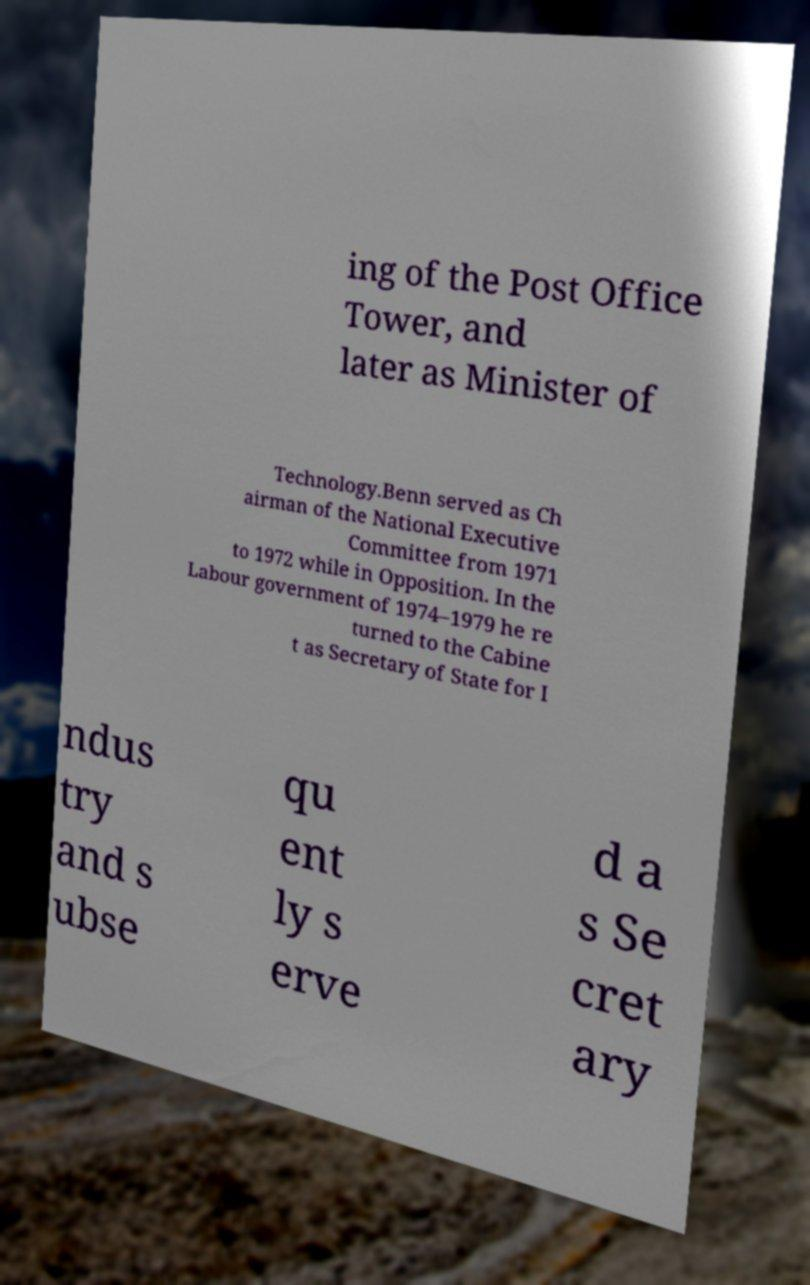Please read and relay the text visible in this image. What does it say? ing of the Post Office Tower, and later as Minister of Technology.Benn served as Ch airman of the National Executive Committee from 1971 to 1972 while in Opposition. In the Labour government of 1974–1979 he re turned to the Cabine t as Secretary of State for I ndus try and s ubse qu ent ly s erve d a s Se cret ary 